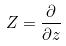Convert formula to latex. <formula><loc_0><loc_0><loc_500><loc_500>Z = \frac { \partial } { \partial z }</formula> 